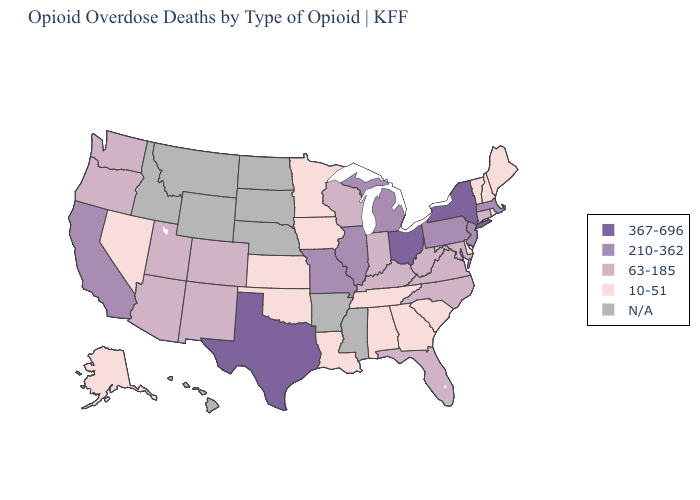Does New York have the highest value in the Northeast?
Concise answer only. Yes. What is the lowest value in the USA?
Quick response, please. 10-51. Which states hav the highest value in the South?
Quick response, please. Texas. What is the lowest value in the South?
Be succinct. 10-51. Name the states that have a value in the range 210-362?
Write a very short answer. California, Illinois, Massachusetts, Michigan, Missouri, New Jersey, Pennsylvania. Name the states that have a value in the range N/A?
Short answer required. Arkansas, Hawaii, Idaho, Mississippi, Montana, Nebraska, North Dakota, South Dakota, Wyoming. Which states hav the highest value in the MidWest?
Write a very short answer. Ohio. What is the lowest value in states that border Georgia?
Concise answer only. 10-51. What is the value of Hawaii?
Be succinct. N/A. What is the highest value in the West ?
Give a very brief answer. 210-362. Name the states that have a value in the range 367-696?
Keep it brief. New York, Ohio, Texas. What is the value of Georgia?
Short answer required. 10-51. Name the states that have a value in the range 10-51?
Concise answer only. Alabama, Alaska, Delaware, Georgia, Iowa, Kansas, Louisiana, Maine, Minnesota, Nevada, New Hampshire, Oklahoma, Rhode Island, South Carolina, Tennessee, Vermont. 